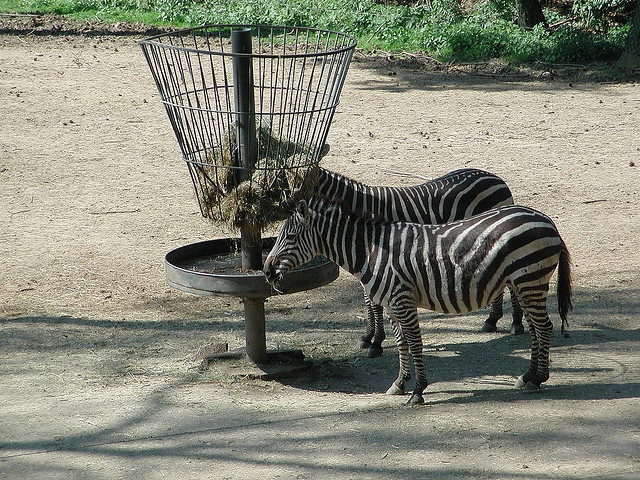Describe the objects in this image and their specific colors. I can see zebra in green, black, gray, and darkgray tones and zebra in green, black, gray, darkgray, and lightgray tones in this image. 